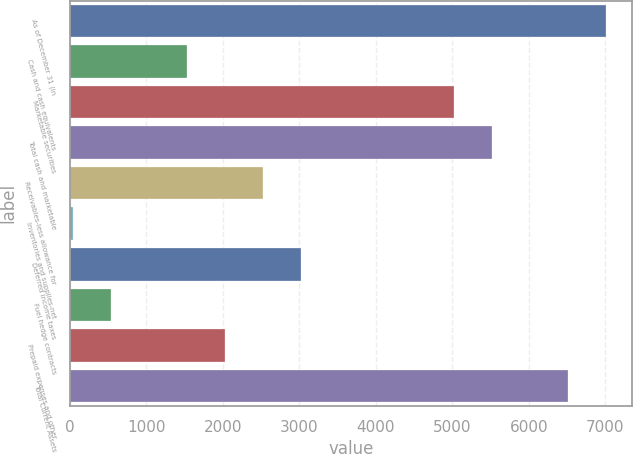Convert chart to OTSL. <chart><loc_0><loc_0><loc_500><loc_500><bar_chart><fcel>As of December 31 (in<fcel>Cash and cash equivalents<fcel>Marketable securities<fcel>Total cash and marketable<fcel>Receivables-less allowance for<fcel>Inventories and supplies-net<fcel>Deferred income taxes<fcel>Fuel hedge contracts<fcel>Prepaid expenses and other<fcel>Total Current Assets<nl><fcel>7005.2<fcel>1536.55<fcel>5016.6<fcel>5513.75<fcel>2530.85<fcel>45.1<fcel>3028<fcel>542.25<fcel>2033.7<fcel>6508.05<nl></chart> 